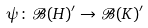Convert formula to latex. <formula><loc_0><loc_0><loc_500><loc_500>\psi \colon \mathcal { B } ( H ) ^ { \prime } \to \mathcal { B } ( K ) ^ { \prime }</formula> 